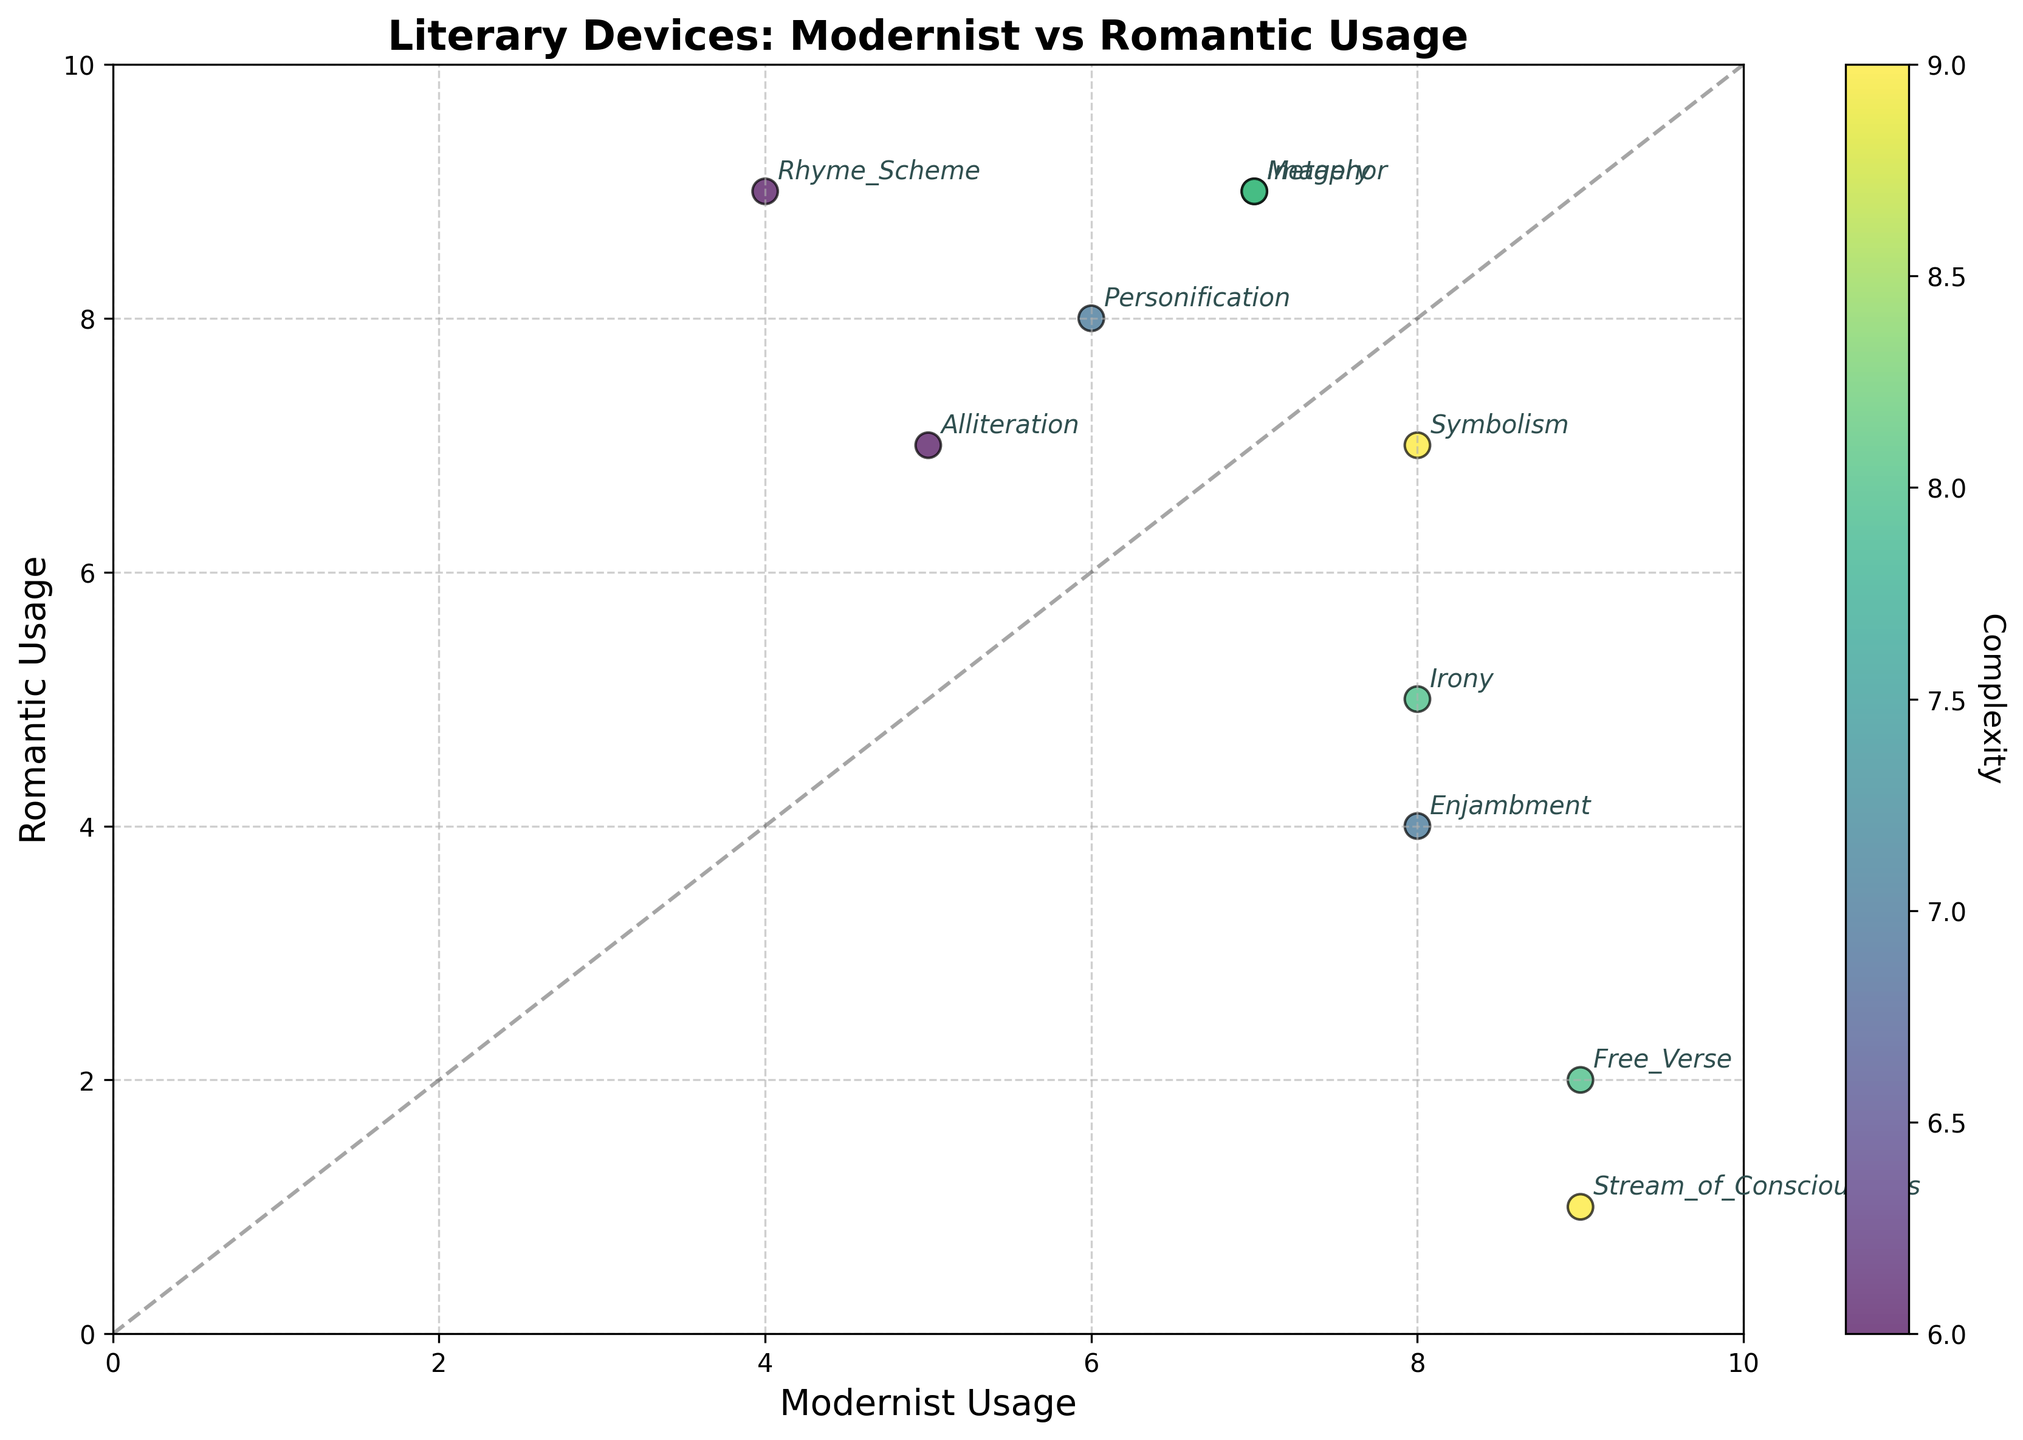How many literary devices are featured in the plot? To determine the number of literary devices, count the number of labels on the plot. Each point represents a distinct literary device
Answer: 10 Which literary device has the highest complexity score? To find the highest complexity score, look at the color gradient and reference the color bar. The literary device with the deepest color (towards the end of the color bar) has the highest complexity.
Answer: Stream_of_Consciousness What is the usage difference in Free Verse between the Modernist and Romantic periods? Locate the Free Verse point on the plot. Subtract the Romantic Usage value from the Modernist Usage value as represented on the x and y axes respectively.
Answer: 7 Which era uses Enjambment more frequently? Compare the coordinates of Enjambment on the x-axis (Modernist Usage) and y-axis (Romantic Usage). The higher value indicates more frequent usage.
Answer: Modernist What is the average complexity score of Metaphor and Personification? First, find the complexity scores of Metaphor and Personification from the color bar reference. Sum these values and divide by 2 for the average.
Answer: 7.5 How does the usage of Symbolism differ between Modernist and Romantic periods? Locate the Symbolism point and compare its x-axis (Modernist Usage) and y-axis (Romantic Usage) values. Compute the difference between these values.
Answer: 1 Are there any devices more complex but less emotionally impactful in modernist poetry? Identify points on the plot within the Modernist Usage high range and reference their complexity and emotional impact. Look for points where complexity exceeds the emotional impact.
Answer: Irony Which literary device shows the most significant usage increase from the Romantic to Modernist periods? Find the device whose Modernist Usage value significantly exceeds its Romantic Usage value considering positions on the axes.
Answer: Free_Verse Between Imagery and Rhyme Scheme, which device has a higher complexity score and where is it more commonly used? Compare the color gradient for complexity and the positions for usage on both axes for Imagery and Rhyme Scheme. Note the higher complexity score and the axis with a higher usage value.
Answer: Imagery, Modernist List all literary devices with usage below 5 in the Romantic period. Check the y-axis values and find points below 5, then read the labels for those points.
Answer: Free_Verse, Stream_of_Consciousness 